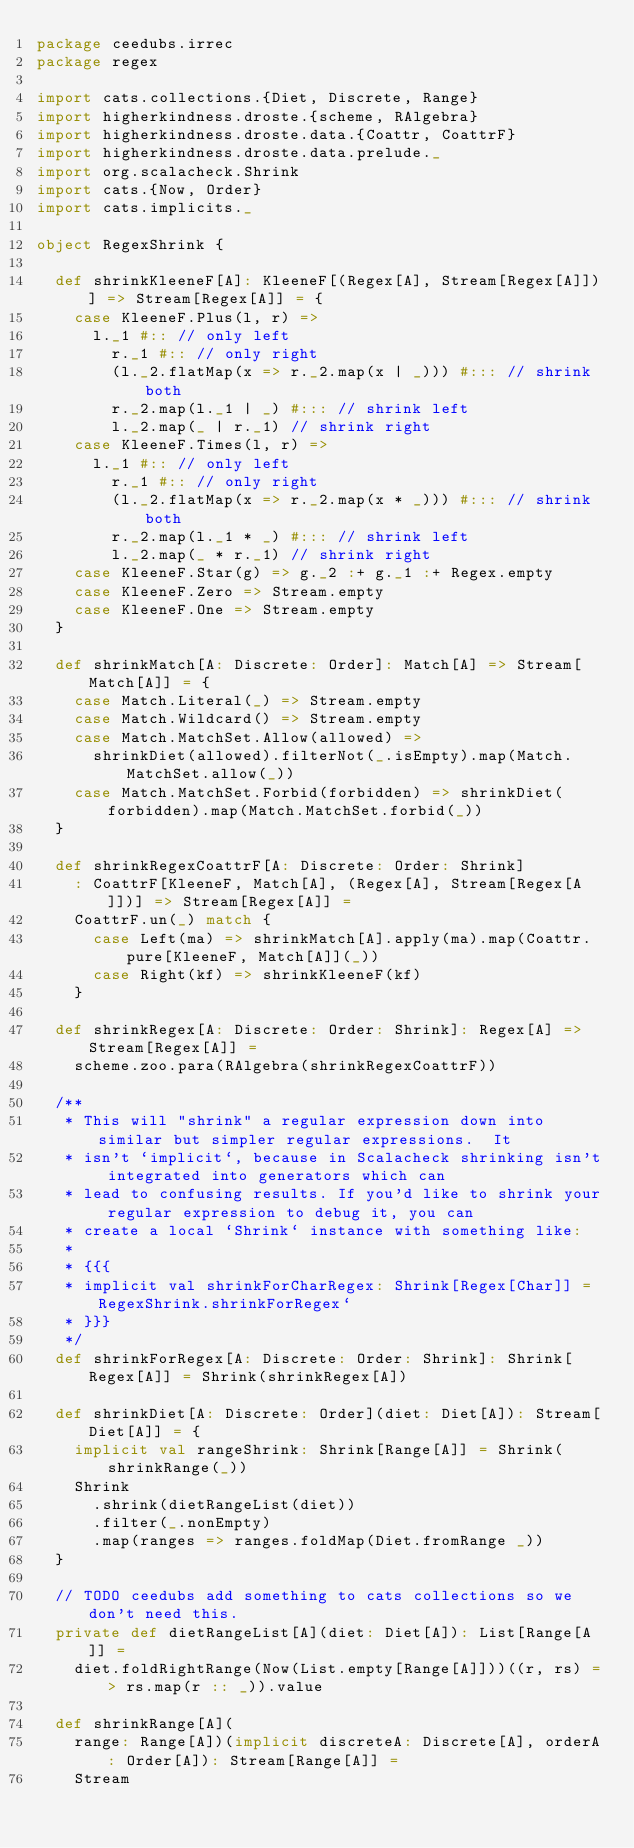Convert code to text. <code><loc_0><loc_0><loc_500><loc_500><_Scala_>package ceedubs.irrec
package regex

import cats.collections.{Diet, Discrete, Range}
import higherkindness.droste.{scheme, RAlgebra}
import higherkindness.droste.data.{Coattr, CoattrF}
import higherkindness.droste.data.prelude._
import org.scalacheck.Shrink
import cats.{Now, Order}
import cats.implicits._

object RegexShrink {

  def shrinkKleeneF[A]: KleeneF[(Regex[A], Stream[Regex[A]])] => Stream[Regex[A]] = {
    case KleeneF.Plus(l, r) =>
      l._1 #:: // only left
        r._1 #:: // only right
        (l._2.flatMap(x => r._2.map(x | _))) #::: // shrink both
        r._2.map(l._1 | _) #::: // shrink left
        l._2.map(_ | r._1) // shrink right
    case KleeneF.Times(l, r) =>
      l._1 #:: // only left
        r._1 #:: // only right
        (l._2.flatMap(x => r._2.map(x * _))) #::: // shrink both
        r._2.map(l._1 * _) #::: // shrink left
        l._2.map(_ * r._1) // shrink right
    case KleeneF.Star(g) => g._2 :+ g._1 :+ Regex.empty
    case KleeneF.Zero => Stream.empty
    case KleeneF.One => Stream.empty
  }

  def shrinkMatch[A: Discrete: Order]: Match[A] => Stream[Match[A]] = {
    case Match.Literal(_) => Stream.empty
    case Match.Wildcard() => Stream.empty
    case Match.MatchSet.Allow(allowed) =>
      shrinkDiet(allowed).filterNot(_.isEmpty).map(Match.MatchSet.allow(_))
    case Match.MatchSet.Forbid(forbidden) => shrinkDiet(forbidden).map(Match.MatchSet.forbid(_))
  }

  def shrinkRegexCoattrF[A: Discrete: Order: Shrink]
    : CoattrF[KleeneF, Match[A], (Regex[A], Stream[Regex[A]])] => Stream[Regex[A]] =
    CoattrF.un(_) match {
      case Left(ma) => shrinkMatch[A].apply(ma).map(Coattr.pure[KleeneF, Match[A]](_))
      case Right(kf) => shrinkKleeneF(kf)
    }

  def shrinkRegex[A: Discrete: Order: Shrink]: Regex[A] => Stream[Regex[A]] =
    scheme.zoo.para(RAlgebra(shrinkRegexCoattrF))

  /**
   * This will "shrink" a regular expression down into similar but simpler regular expressions.  It
   * isn't `implicit`, because in Scalacheck shrinking isn't integrated into generators which can
   * lead to confusing results. If you'd like to shrink your regular expression to debug it, you can
   * create a local `Shrink` instance with something like:
   *
   * {{{
   * implicit val shrinkForCharRegex: Shrink[Regex[Char]] = RegexShrink.shrinkForRegex`
   * }}}
   */
  def shrinkForRegex[A: Discrete: Order: Shrink]: Shrink[Regex[A]] = Shrink(shrinkRegex[A])

  def shrinkDiet[A: Discrete: Order](diet: Diet[A]): Stream[Diet[A]] = {
    implicit val rangeShrink: Shrink[Range[A]] = Shrink(shrinkRange(_))
    Shrink
      .shrink(dietRangeList(diet))
      .filter(_.nonEmpty)
      .map(ranges => ranges.foldMap(Diet.fromRange _))
  }

  // TODO ceedubs add something to cats collections so we don't need this.
  private def dietRangeList[A](diet: Diet[A]): List[Range[A]] =
    diet.foldRightRange(Now(List.empty[Range[A]]))((r, rs) => rs.map(r :: _)).value

  def shrinkRange[A](
    range: Range[A])(implicit discreteA: Discrete[A], orderA: Order[A]): Stream[Range[A]] =
    Stream</code> 